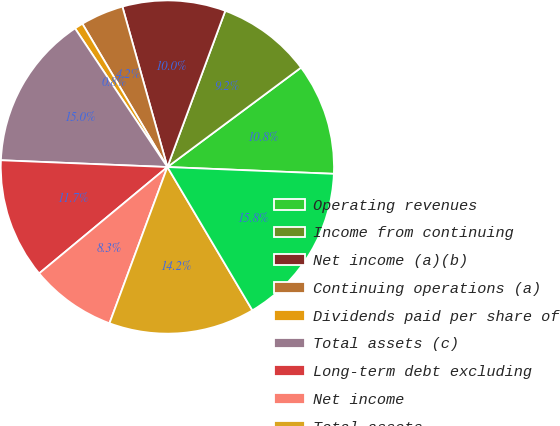Convert chart. <chart><loc_0><loc_0><loc_500><loc_500><pie_chart><fcel>Operating revenues<fcel>Income from continuing<fcel>Net income (a)(b)<fcel>Continuing operations (a)<fcel>Dividends paid per share of<fcel>Total assets (c)<fcel>Long-term debt excluding<fcel>Net income<fcel>Total assets<fcel>Energy sales (kWh)<nl><fcel>10.83%<fcel>9.17%<fcel>10.0%<fcel>4.17%<fcel>0.83%<fcel>15.0%<fcel>11.67%<fcel>8.33%<fcel>14.17%<fcel>15.83%<nl></chart> 